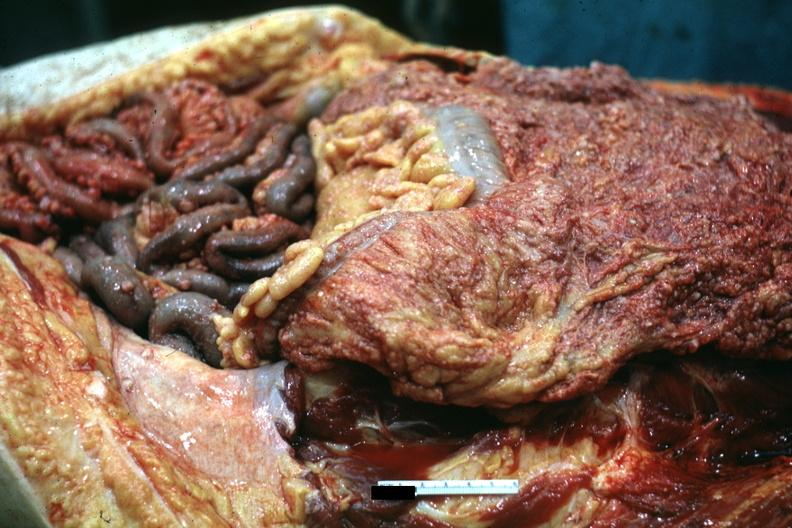s carcinomatosis present?
Answer the question using a single word or phrase. Yes 